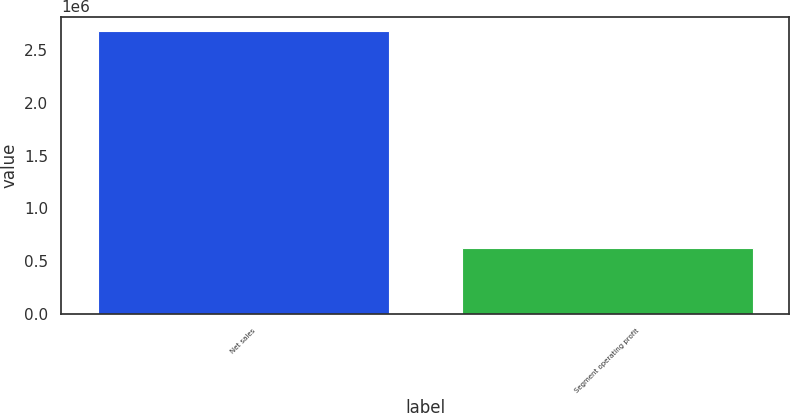Convert chart. <chart><loc_0><loc_0><loc_500><loc_500><bar_chart><fcel>Net sales<fcel>Segment operating profit<nl><fcel>2.68098e+06<fcel>623412<nl></chart> 